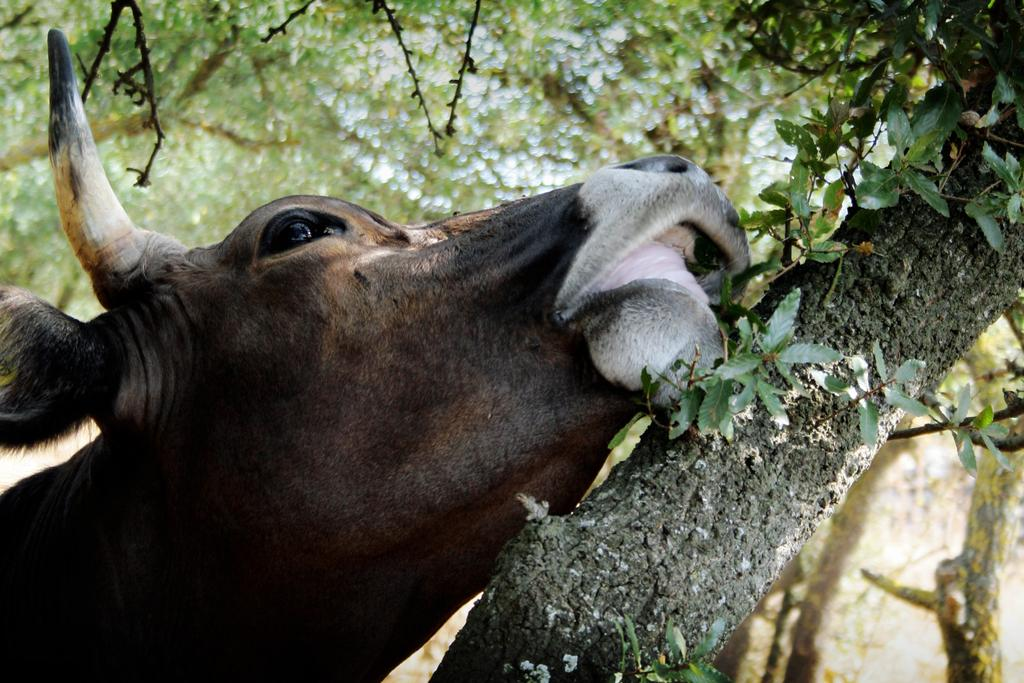What type of animal is in the image? There is an animal in the image, but its specific type cannot be determined from the provided facts. What colors can be seen on the animal? The animal has black, white, and brown colors. What is located near the animal in the image? There is a tree in the image. What is the condition of the tree in the image? The tree has leaves. What can be seen in the background of the image? There are more trees visible in the background of the image. Can you see any sea creatures in the image? There is no sea or sea creatures present in the image; it features an animal and trees. What type of feather can be seen on the animal in the image? There is no feather visible on the animal in the image. 